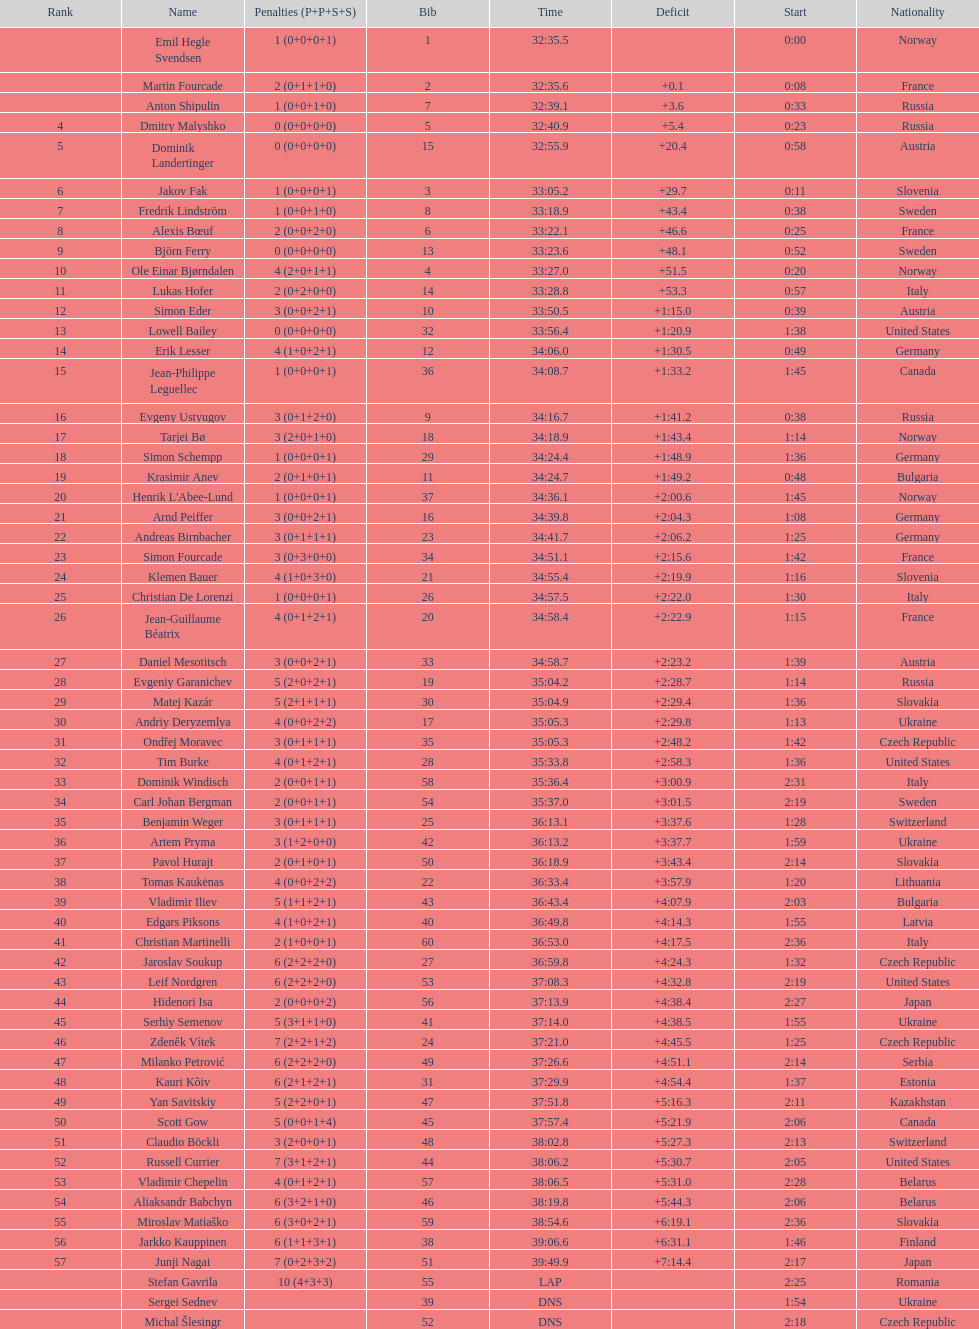Between bjorn ferry, simon elder and erik lesser - who had the most penalties? Erik Lesser. 